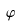Convert formula to latex. <formula><loc_0><loc_0><loc_500><loc_500>\varphi</formula> 